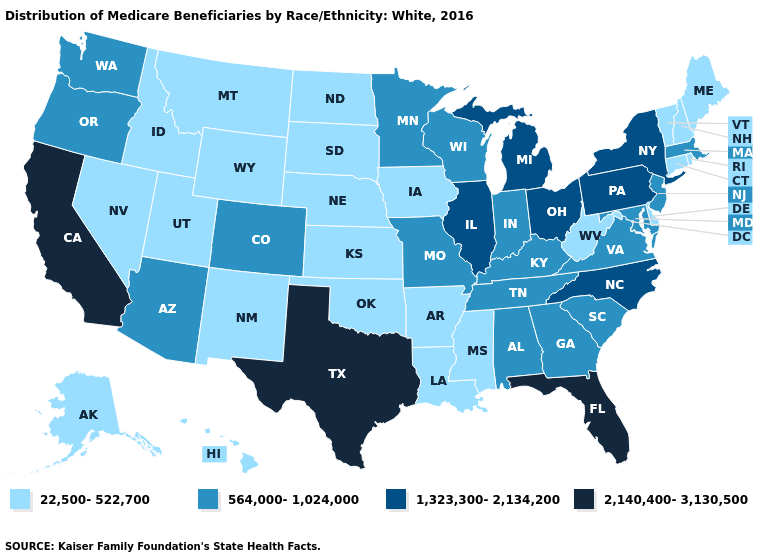Does Kansas have the highest value in the MidWest?
Quick response, please. No. What is the lowest value in the Northeast?
Concise answer only. 22,500-522,700. What is the highest value in states that border Connecticut?
Quick response, please. 1,323,300-2,134,200. Does New York have a lower value than Maryland?
Concise answer only. No. Does Idaho have a higher value than Illinois?
Quick response, please. No. Name the states that have a value in the range 1,323,300-2,134,200?
Be succinct. Illinois, Michigan, New York, North Carolina, Ohio, Pennsylvania. Does Arizona have a higher value than Louisiana?
Be succinct. Yes. Does Minnesota have a lower value than Michigan?
Give a very brief answer. Yes. Does Louisiana have a higher value than Alabama?
Answer briefly. No. What is the value of Iowa?
Short answer required. 22,500-522,700. What is the value of South Dakota?
Keep it brief. 22,500-522,700. Does the first symbol in the legend represent the smallest category?
Be succinct. Yes. Name the states that have a value in the range 1,323,300-2,134,200?
Be succinct. Illinois, Michigan, New York, North Carolina, Ohio, Pennsylvania. Which states have the lowest value in the MidWest?
Answer briefly. Iowa, Kansas, Nebraska, North Dakota, South Dakota. Name the states that have a value in the range 564,000-1,024,000?
Concise answer only. Alabama, Arizona, Colorado, Georgia, Indiana, Kentucky, Maryland, Massachusetts, Minnesota, Missouri, New Jersey, Oregon, South Carolina, Tennessee, Virginia, Washington, Wisconsin. 